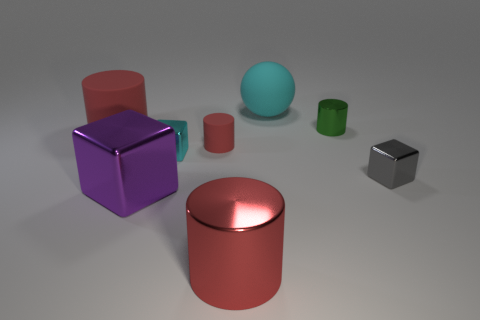What material is the other tiny thing that is the same shape as the small red rubber thing? Based on the image, the other small object with a shape similar to the small red item appears to be made of metal, as indicated by its reflective surface and the way it interacts with light. 